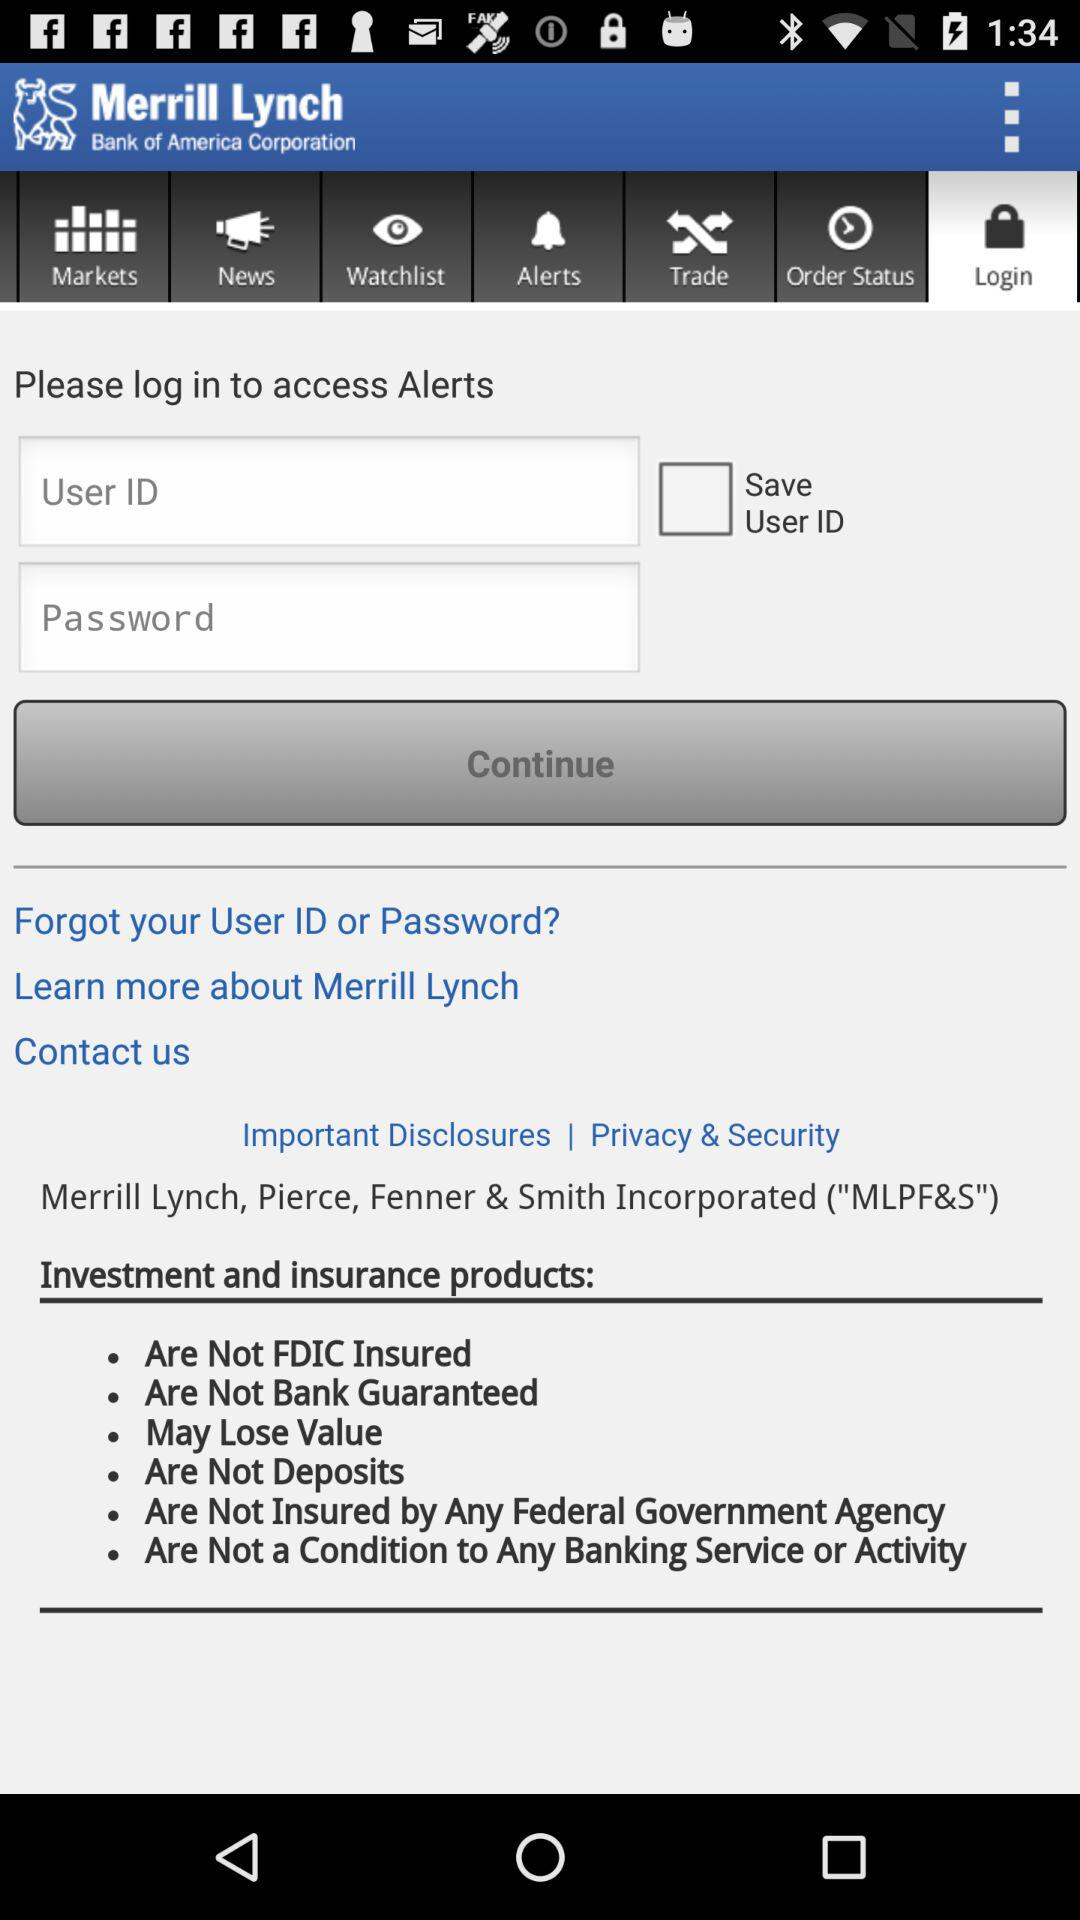On which tab of the application is the user? The tab is "Login". 